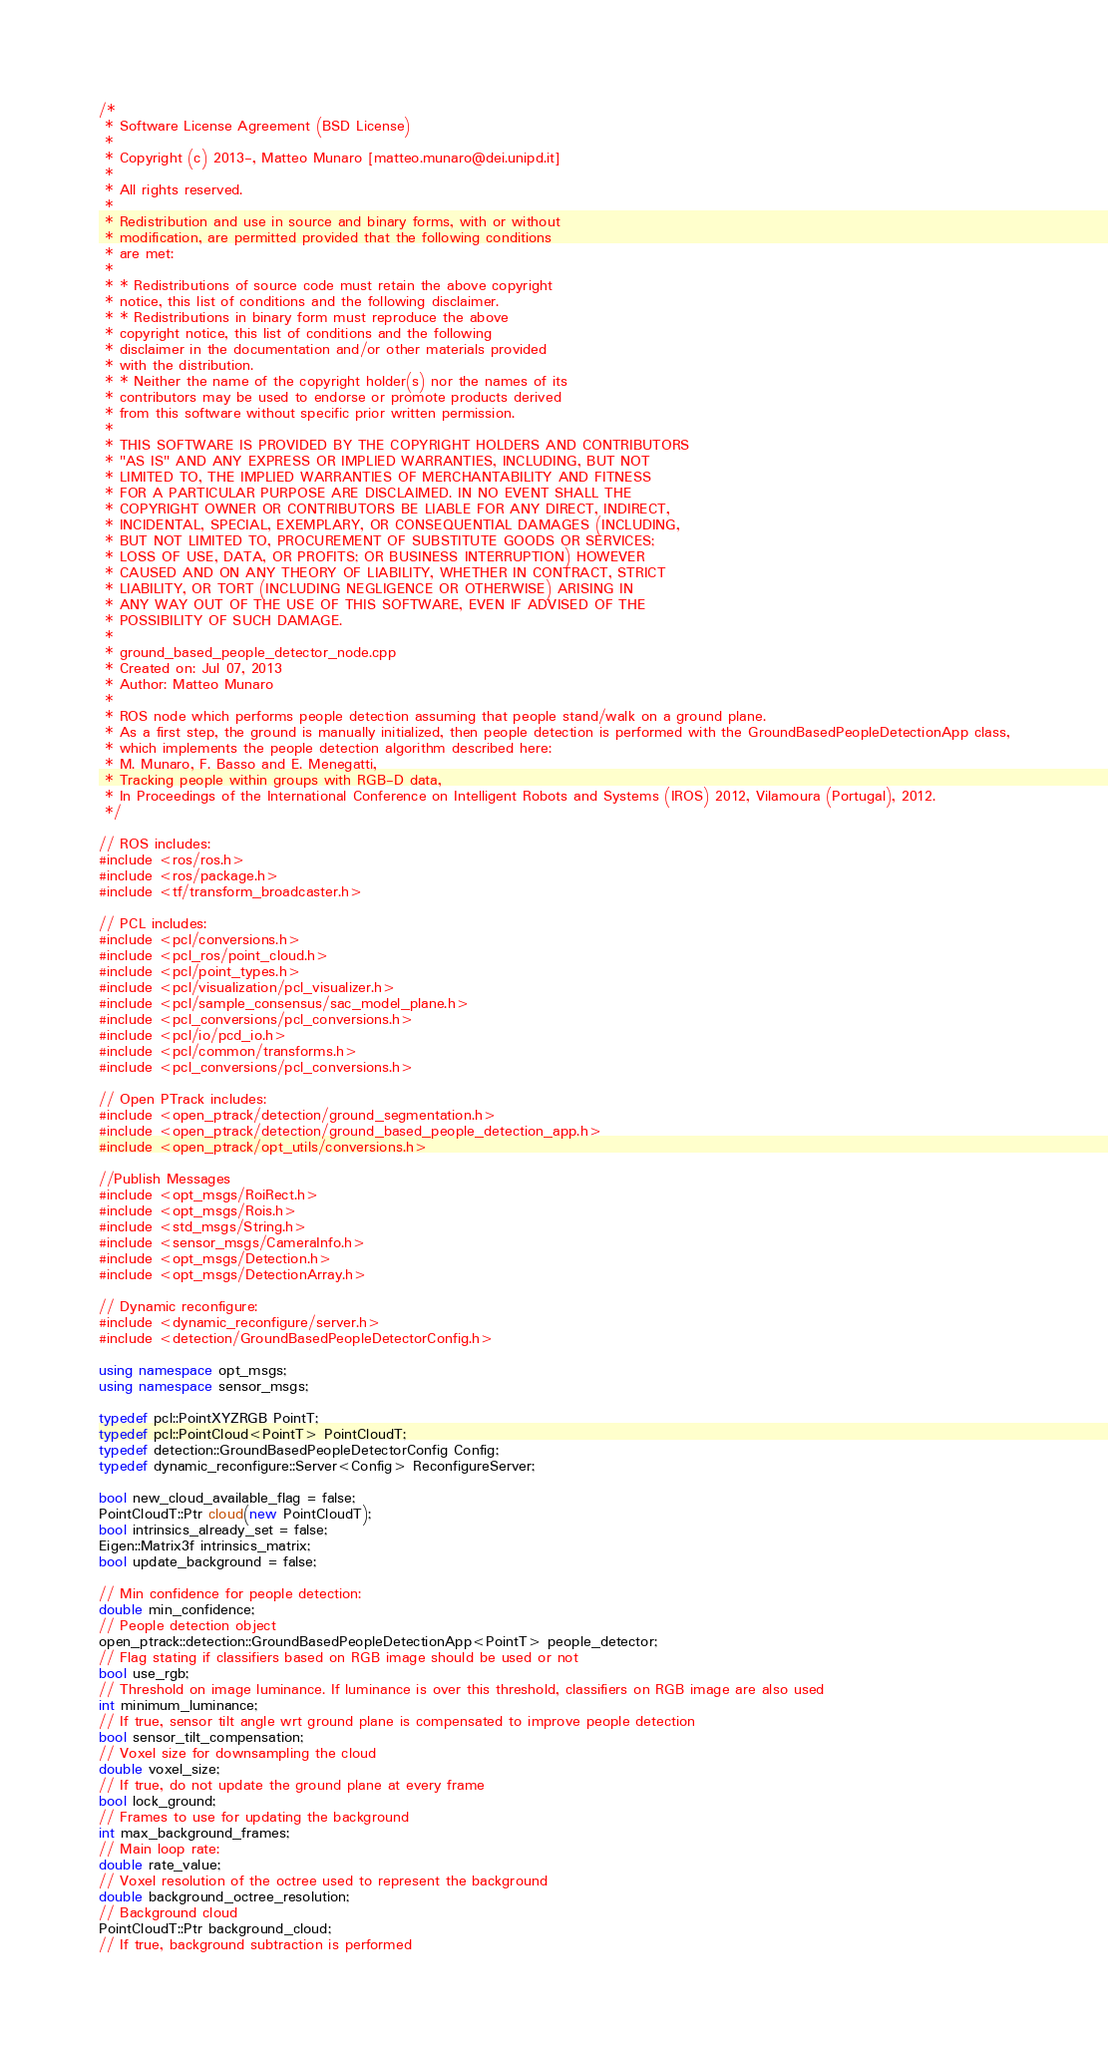Convert code to text. <code><loc_0><loc_0><loc_500><loc_500><_C++_>
/*
 * Software License Agreement (BSD License)
 *
 * Copyright (c) 2013-, Matteo Munaro [matteo.munaro@dei.unipd.it]
 *
 * All rights reserved.
 *
 * Redistribution and use in source and binary forms, with or without
 * modification, are permitted provided that the following conditions
 * are met:
 *
 * * Redistributions of source code must retain the above copyright
 * notice, this list of conditions and the following disclaimer.
 * * Redistributions in binary form must reproduce the above
 * copyright notice, this list of conditions and the following
 * disclaimer in the documentation and/or other materials provided
 * with the distribution.
 * * Neither the name of the copyright holder(s) nor the names of its
 * contributors may be used to endorse or promote products derived
 * from this software without specific prior written permission.
 *
 * THIS SOFTWARE IS PROVIDED BY THE COPYRIGHT HOLDERS AND CONTRIBUTORS
 * "AS IS" AND ANY EXPRESS OR IMPLIED WARRANTIES, INCLUDING, BUT NOT
 * LIMITED TO, THE IMPLIED WARRANTIES OF MERCHANTABILITY AND FITNESS
 * FOR A PARTICULAR PURPOSE ARE DISCLAIMED. IN NO EVENT SHALL THE
 * COPYRIGHT OWNER OR CONTRIBUTORS BE LIABLE FOR ANY DIRECT, INDIRECT,
 * INCIDENTAL, SPECIAL, EXEMPLARY, OR CONSEQUENTIAL DAMAGES (INCLUDING,
 * BUT NOT LIMITED TO, PROCUREMENT OF SUBSTITUTE GOODS OR SERVICES;
 * LOSS OF USE, DATA, OR PROFITS; OR BUSINESS INTERRUPTION) HOWEVER
 * CAUSED AND ON ANY THEORY OF LIABILITY, WHETHER IN CONTRACT, STRICT
 * LIABILITY, OR TORT (INCLUDING NEGLIGENCE OR OTHERWISE) ARISING IN
 * ANY WAY OUT OF THE USE OF THIS SOFTWARE, EVEN IF ADVISED OF THE
 * POSSIBILITY OF SUCH DAMAGE.
 *
 * ground_based_people_detector_node.cpp
 * Created on: Jul 07, 2013
 * Author: Matteo Munaro
 *
 * ROS node which performs people detection assuming that people stand/walk on a ground plane.
 * As a first step, the ground is manually initialized, then people detection is performed with the GroundBasedPeopleDetectionApp class,
 * which implements the people detection algorithm described here:
 * M. Munaro, F. Basso and E. Menegatti,
 * Tracking people within groups with RGB-D data,
 * In Proceedings of the International Conference on Intelligent Robots and Systems (IROS) 2012, Vilamoura (Portugal), 2012.
 */

// ROS includes:
#include <ros/ros.h>
#include <ros/package.h>
#include <tf/transform_broadcaster.h>

// PCL includes:
#include <pcl/conversions.h>
#include <pcl_ros/point_cloud.h>
#include <pcl/point_types.h>
#include <pcl/visualization/pcl_visualizer.h>
#include <pcl/sample_consensus/sac_model_plane.h>
#include <pcl_conversions/pcl_conversions.h>
#include <pcl/io/pcd_io.h>
#include <pcl/common/transforms.h>
#include <pcl_conversions/pcl_conversions.h>

// Open PTrack includes:
#include <open_ptrack/detection/ground_segmentation.h>
#include <open_ptrack/detection/ground_based_people_detection_app.h>
#include <open_ptrack/opt_utils/conversions.h>

//Publish Messages
#include <opt_msgs/RoiRect.h>
#include <opt_msgs/Rois.h>
#include <std_msgs/String.h>
#include <sensor_msgs/CameraInfo.h>
#include <opt_msgs/Detection.h>
#include <opt_msgs/DetectionArray.h>

// Dynamic reconfigure:
#include <dynamic_reconfigure/server.h>
#include <detection/GroundBasedPeopleDetectorConfig.h>

using namespace opt_msgs;
using namespace sensor_msgs;

typedef pcl::PointXYZRGB PointT;
typedef pcl::PointCloud<PointT> PointCloudT;
typedef detection::GroundBasedPeopleDetectorConfig Config;
typedef dynamic_reconfigure::Server<Config> ReconfigureServer;

bool new_cloud_available_flag = false;
PointCloudT::Ptr cloud(new PointCloudT);
bool intrinsics_already_set = false;
Eigen::Matrix3f intrinsics_matrix;
bool update_background = false;

// Min confidence for people detection:
double min_confidence;
// People detection object
open_ptrack::detection::GroundBasedPeopleDetectionApp<PointT> people_detector;
// Flag stating if classifiers based on RGB image should be used or not
bool use_rgb;
// Threshold on image luminance. If luminance is over this threshold, classifiers on RGB image are also used
int minimum_luminance;
// If true, sensor tilt angle wrt ground plane is compensated to improve people detection
bool sensor_tilt_compensation;
// Voxel size for downsampling the cloud
double voxel_size;
// If true, do not update the ground plane at every frame
bool lock_ground;
// Frames to use for updating the background
int max_background_frames;
// Main loop rate:
double rate_value;
// Voxel resolution of the octree used to represent the background
double background_octree_resolution;
// Background cloud
PointCloudT::Ptr background_cloud;
// If true, background subtraction is performed</code> 